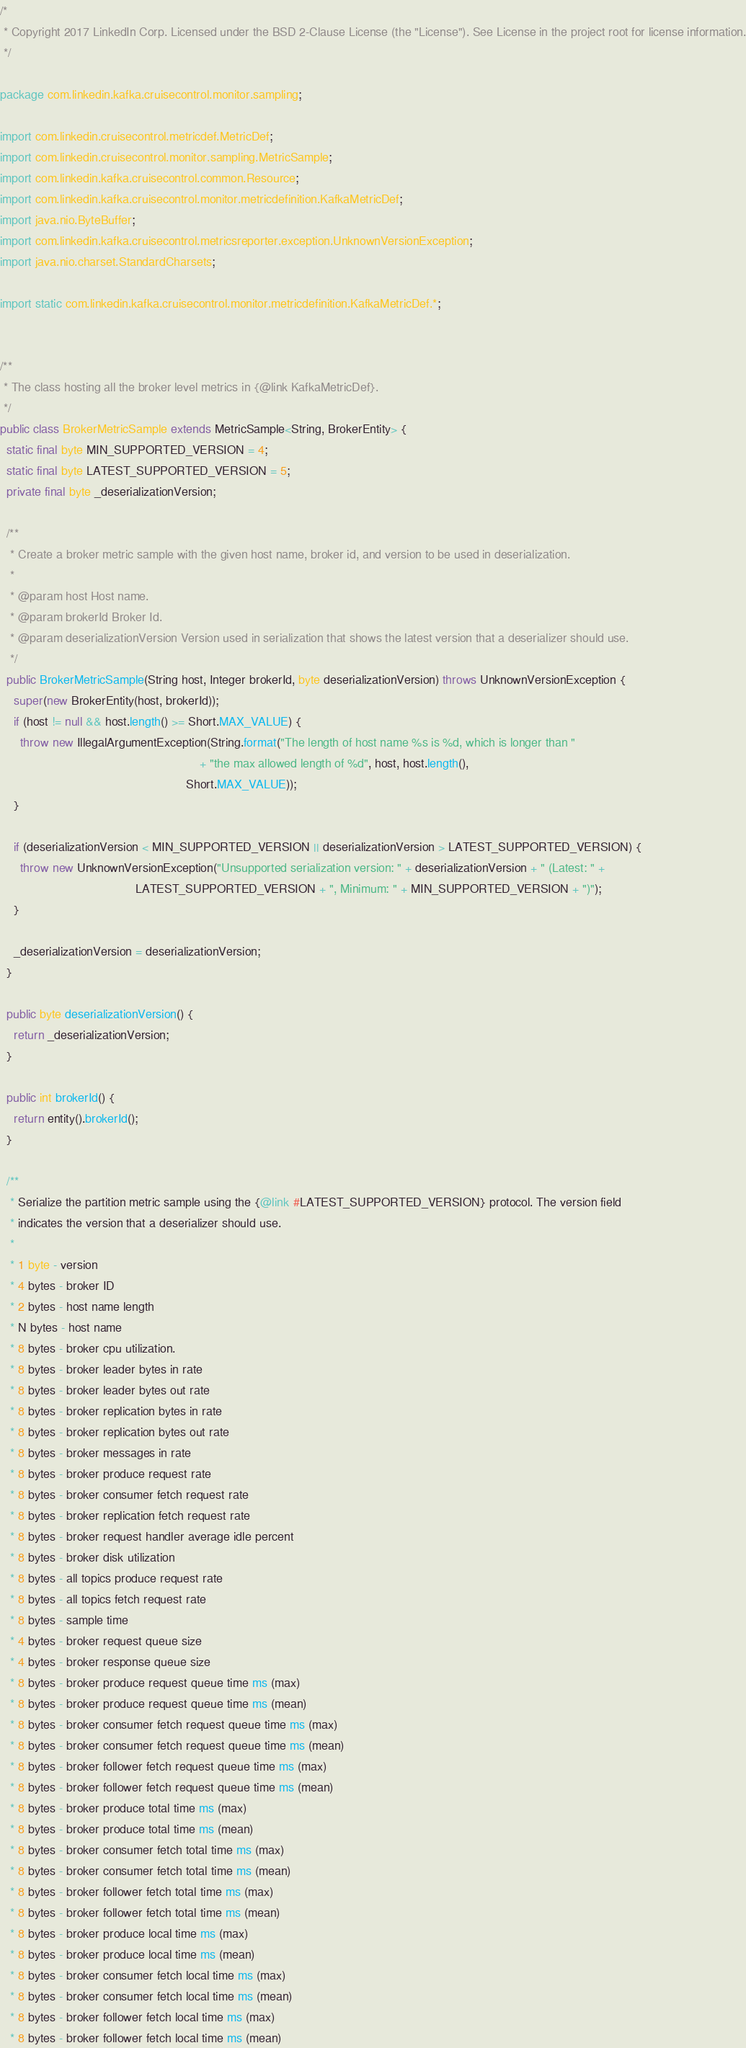<code> <loc_0><loc_0><loc_500><loc_500><_Java_>/*
 * Copyright 2017 LinkedIn Corp. Licensed under the BSD 2-Clause License (the "License"). See License in the project root for license information.
 */

package com.linkedin.kafka.cruisecontrol.monitor.sampling;

import com.linkedin.cruisecontrol.metricdef.MetricDef;
import com.linkedin.cruisecontrol.monitor.sampling.MetricSample;
import com.linkedin.kafka.cruisecontrol.common.Resource;
import com.linkedin.kafka.cruisecontrol.monitor.metricdefinition.KafkaMetricDef;
import java.nio.ByteBuffer;
import com.linkedin.kafka.cruisecontrol.metricsreporter.exception.UnknownVersionException;
import java.nio.charset.StandardCharsets;

import static com.linkedin.kafka.cruisecontrol.monitor.metricdefinition.KafkaMetricDef.*;


/**
 * The class hosting all the broker level metrics in {@link KafkaMetricDef}.
 */
public class BrokerMetricSample extends MetricSample<String, BrokerEntity> {
  static final byte MIN_SUPPORTED_VERSION = 4;
  static final byte LATEST_SUPPORTED_VERSION = 5;
  private final byte _deserializationVersion;

  /**
   * Create a broker metric sample with the given host name, broker id, and version to be used in deserialization.
   *
   * @param host Host name.
   * @param brokerId Broker Id.
   * @param deserializationVersion Version used in serialization that shows the latest version that a deserializer should use.
   */
  public BrokerMetricSample(String host, Integer brokerId, byte deserializationVersion) throws UnknownVersionException {
    super(new BrokerEntity(host, brokerId));
    if (host != null && host.length() >= Short.MAX_VALUE) {
      throw new IllegalArgumentException(String.format("The length of host name %s is %d, which is longer than "
                                                           + "the max allowed length of %d", host, host.length(),
                                                       Short.MAX_VALUE));
    }

    if (deserializationVersion < MIN_SUPPORTED_VERSION || deserializationVersion > LATEST_SUPPORTED_VERSION) {
      throw new UnknownVersionException("Unsupported serialization version: " + deserializationVersion + " (Latest: " +
                                        LATEST_SUPPORTED_VERSION + ", Minimum: " + MIN_SUPPORTED_VERSION + ")");
    }

    _deserializationVersion = deserializationVersion;
  }

  public byte deserializationVersion() {
    return _deserializationVersion;
  }

  public int brokerId() {
    return entity().brokerId();
  }

  /**
   * Serialize the partition metric sample using the {@link #LATEST_SUPPORTED_VERSION} protocol. The version field
   * indicates the version that a deserializer should use.
   *
   * 1 byte - version
   * 4 bytes - broker ID
   * 2 bytes - host name length
   * N bytes - host name
   * 8 bytes - broker cpu utilization.
   * 8 bytes - broker leader bytes in rate
   * 8 bytes - broker leader bytes out rate
   * 8 bytes - broker replication bytes in rate
   * 8 bytes - broker replication bytes out rate
   * 8 bytes - broker messages in rate
   * 8 bytes - broker produce request rate
   * 8 bytes - broker consumer fetch request rate
   * 8 bytes - broker replication fetch request rate
   * 8 bytes - broker request handler average idle percent
   * 8 bytes - broker disk utilization
   * 8 bytes - all topics produce request rate
   * 8 bytes - all topics fetch request rate
   * 8 bytes - sample time
   * 4 bytes - broker request queue size
   * 4 bytes - broker response queue size
   * 8 bytes - broker produce request queue time ms (max)
   * 8 bytes - broker produce request queue time ms (mean)
   * 8 bytes - broker consumer fetch request queue time ms (max)
   * 8 bytes - broker consumer fetch request queue time ms (mean)
   * 8 bytes - broker follower fetch request queue time ms (max)
   * 8 bytes - broker follower fetch request queue time ms (mean)
   * 8 bytes - broker produce total time ms (max)
   * 8 bytes - broker produce total time ms (mean)
   * 8 bytes - broker consumer fetch total time ms (max)
   * 8 bytes - broker consumer fetch total time ms (mean)
   * 8 bytes - broker follower fetch total time ms (max)
   * 8 bytes - broker follower fetch total time ms (mean)
   * 8 bytes - broker produce local time ms (max)
   * 8 bytes - broker produce local time ms (mean)
   * 8 bytes - broker consumer fetch local time ms (max)
   * 8 bytes - broker consumer fetch local time ms (mean)
   * 8 bytes - broker follower fetch local time ms (max)
   * 8 bytes - broker follower fetch local time ms (mean)</code> 